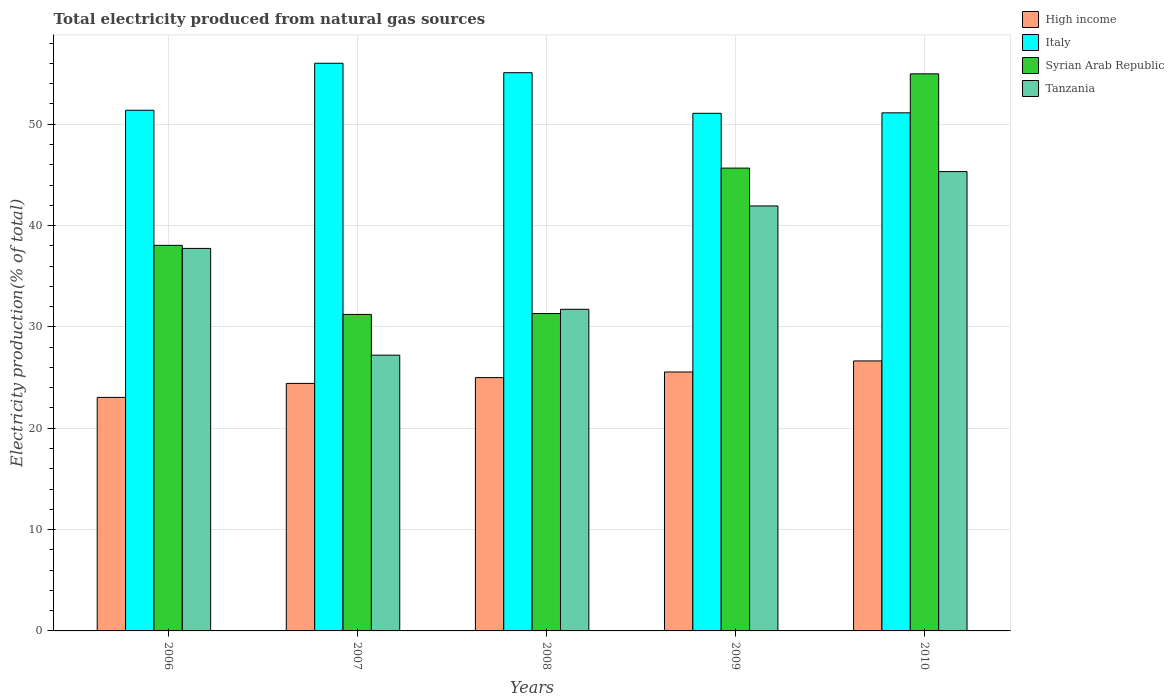Are the number of bars on each tick of the X-axis equal?
Offer a very short reply. Yes. How many bars are there on the 5th tick from the left?
Offer a very short reply. 4. In how many cases, is the number of bars for a given year not equal to the number of legend labels?
Provide a short and direct response. 0. What is the total electricity produced in High income in 2010?
Make the answer very short. 26.64. Across all years, what is the maximum total electricity produced in Syrian Arab Republic?
Offer a terse response. 54.97. Across all years, what is the minimum total electricity produced in Syrian Arab Republic?
Offer a terse response. 31.23. In which year was the total electricity produced in Syrian Arab Republic minimum?
Your response must be concise. 2007. What is the total total electricity produced in Italy in the graph?
Provide a succinct answer. 264.67. What is the difference between the total electricity produced in Syrian Arab Republic in 2006 and that in 2007?
Your answer should be very brief. 6.82. What is the difference between the total electricity produced in Italy in 2007 and the total electricity produced in High income in 2006?
Offer a very short reply. 32.97. What is the average total electricity produced in High income per year?
Provide a succinct answer. 24.93. In the year 2007, what is the difference between the total electricity produced in Tanzania and total electricity produced in Italy?
Make the answer very short. -28.8. What is the ratio of the total electricity produced in High income in 2007 to that in 2009?
Offer a very short reply. 0.96. Is the total electricity produced in High income in 2006 less than that in 2008?
Offer a terse response. Yes. What is the difference between the highest and the second highest total electricity produced in Italy?
Your response must be concise. 0.93. What is the difference between the highest and the lowest total electricity produced in Syrian Arab Republic?
Give a very brief answer. 23.74. In how many years, is the total electricity produced in Italy greater than the average total electricity produced in Italy taken over all years?
Your answer should be compact. 2. Is the sum of the total electricity produced in High income in 2007 and 2008 greater than the maximum total electricity produced in Tanzania across all years?
Keep it short and to the point. Yes. Is it the case that in every year, the sum of the total electricity produced in Italy and total electricity produced in Tanzania is greater than the sum of total electricity produced in Syrian Arab Republic and total electricity produced in High income?
Your response must be concise. No. What does the 1st bar from the left in 2006 represents?
Give a very brief answer. High income. What does the 2nd bar from the right in 2010 represents?
Your response must be concise. Syrian Arab Republic. How many bars are there?
Ensure brevity in your answer.  20. Are all the bars in the graph horizontal?
Ensure brevity in your answer.  No. What is the difference between two consecutive major ticks on the Y-axis?
Make the answer very short. 10. Does the graph contain grids?
Your answer should be very brief. Yes. What is the title of the graph?
Give a very brief answer. Total electricity produced from natural gas sources. What is the label or title of the X-axis?
Your answer should be compact. Years. What is the Electricity production(% of total) of High income in 2006?
Make the answer very short. 23.04. What is the Electricity production(% of total) in Italy in 2006?
Ensure brevity in your answer.  51.38. What is the Electricity production(% of total) in Syrian Arab Republic in 2006?
Ensure brevity in your answer.  38.05. What is the Electricity production(% of total) of Tanzania in 2006?
Your answer should be compact. 37.74. What is the Electricity production(% of total) in High income in 2007?
Your response must be concise. 24.42. What is the Electricity production(% of total) of Italy in 2007?
Make the answer very short. 56.01. What is the Electricity production(% of total) in Syrian Arab Republic in 2007?
Provide a short and direct response. 31.23. What is the Electricity production(% of total) of Tanzania in 2007?
Keep it short and to the point. 27.21. What is the Electricity production(% of total) in High income in 2008?
Provide a succinct answer. 25. What is the Electricity production(% of total) of Italy in 2008?
Provide a short and direct response. 55.08. What is the Electricity production(% of total) of Syrian Arab Republic in 2008?
Your answer should be compact. 31.32. What is the Electricity production(% of total) of Tanzania in 2008?
Give a very brief answer. 31.74. What is the Electricity production(% of total) in High income in 2009?
Offer a very short reply. 25.55. What is the Electricity production(% of total) of Italy in 2009?
Keep it short and to the point. 51.08. What is the Electricity production(% of total) in Syrian Arab Republic in 2009?
Provide a short and direct response. 45.67. What is the Electricity production(% of total) in Tanzania in 2009?
Offer a terse response. 41.93. What is the Electricity production(% of total) of High income in 2010?
Offer a very short reply. 26.64. What is the Electricity production(% of total) in Italy in 2010?
Ensure brevity in your answer.  51.12. What is the Electricity production(% of total) in Syrian Arab Republic in 2010?
Your answer should be compact. 54.97. What is the Electricity production(% of total) in Tanzania in 2010?
Offer a very short reply. 45.32. Across all years, what is the maximum Electricity production(% of total) of High income?
Your answer should be very brief. 26.64. Across all years, what is the maximum Electricity production(% of total) in Italy?
Give a very brief answer. 56.01. Across all years, what is the maximum Electricity production(% of total) in Syrian Arab Republic?
Offer a terse response. 54.97. Across all years, what is the maximum Electricity production(% of total) in Tanzania?
Your answer should be very brief. 45.32. Across all years, what is the minimum Electricity production(% of total) in High income?
Keep it short and to the point. 23.04. Across all years, what is the minimum Electricity production(% of total) of Italy?
Make the answer very short. 51.08. Across all years, what is the minimum Electricity production(% of total) in Syrian Arab Republic?
Keep it short and to the point. 31.23. Across all years, what is the minimum Electricity production(% of total) in Tanzania?
Offer a very short reply. 27.21. What is the total Electricity production(% of total) in High income in the graph?
Your answer should be compact. 124.65. What is the total Electricity production(% of total) of Italy in the graph?
Your answer should be compact. 264.67. What is the total Electricity production(% of total) in Syrian Arab Republic in the graph?
Provide a succinct answer. 201.23. What is the total Electricity production(% of total) in Tanzania in the graph?
Keep it short and to the point. 183.95. What is the difference between the Electricity production(% of total) of High income in 2006 and that in 2007?
Ensure brevity in your answer.  -1.38. What is the difference between the Electricity production(% of total) in Italy in 2006 and that in 2007?
Make the answer very short. -4.64. What is the difference between the Electricity production(% of total) of Syrian Arab Republic in 2006 and that in 2007?
Provide a succinct answer. 6.82. What is the difference between the Electricity production(% of total) of Tanzania in 2006 and that in 2007?
Provide a succinct answer. 10.53. What is the difference between the Electricity production(% of total) in High income in 2006 and that in 2008?
Make the answer very short. -1.95. What is the difference between the Electricity production(% of total) in Italy in 2006 and that in 2008?
Your answer should be compact. -3.71. What is the difference between the Electricity production(% of total) of Syrian Arab Republic in 2006 and that in 2008?
Your response must be concise. 6.73. What is the difference between the Electricity production(% of total) of Tanzania in 2006 and that in 2008?
Your answer should be very brief. 6.01. What is the difference between the Electricity production(% of total) of High income in 2006 and that in 2009?
Make the answer very short. -2.51. What is the difference between the Electricity production(% of total) in Italy in 2006 and that in 2009?
Keep it short and to the point. 0.3. What is the difference between the Electricity production(% of total) in Syrian Arab Republic in 2006 and that in 2009?
Your response must be concise. -7.62. What is the difference between the Electricity production(% of total) of Tanzania in 2006 and that in 2009?
Offer a terse response. -4.19. What is the difference between the Electricity production(% of total) of High income in 2006 and that in 2010?
Provide a short and direct response. -3.6. What is the difference between the Electricity production(% of total) of Italy in 2006 and that in 2010?
Your response must be concise. 0.25. What is the difference between the Electricity production(% of total) in Syrian Arab Republic in 2006 and that in 2010?
Your answer should be very brief. -16.92. What is the difference between the Electricity production(% of total) of Tanzania in 2006 and that in 2010?
Your answer should be compact. -7.58. What is the difference between the Electricity production(% of total) in High income in 2007 and that in 2008?
Give a very brief answer. -0.57. What is the difference between the Electricity production(% of total) in Italy in 2007 and that in 2008?
Keep it short and to the point. 0.93. What is the difference between the Electricity production(% of total) of Syrian Arab Republic in 2007 and that in 2008?
Provide a succinct answer. -0.09. What is the difference between the Electricity production(% of total) in Tanzania in 2007 and that in 2008?
Offer a very short reply. -4.53. What is the difference between the Electricity production(% of total) in High income in 2007 and that in 2009?
Your response must be concise. -1.13. What is the difference between the Electricity production(% of total) of Italy in 2007 and that in 2009?
Make the answer very short. 4.94. What is the difference between the Electricity production(% of total) in Syrian Arab Republic in 2007 and that in 2009?
Provide a succinct answer. -14.44. What is the difference between the Electricity production(% of total) of Tanzania in 2007 and that in 2009?
Ensure brevity in your answer.  -14.72. What is the difference between the Electricity production(% of total) in High income in 2007 and that in 2010?
Make the answer very short. -2.22. What is the difference between the Electricity production(% of total) of Italy in 2007 and that in 2010?
Provide a short and direct response. 4.89. What is the difference between the Electricity production(% of total) in Syrian Arab Republic in 2007 and that in 2010?
Give a very brief answer. -23.74. What is the difference between the Electricity production(% of total) of Tanzania in 2007 and that in 2010?
Give a very brief answer. -18.11. What is the difference between the Electricity production(% of total) of High income in 2008 and that in 2009?
Ensure brevity in your answer.  -0.56. What is the difference between the Electricity production(% of total) of Italy in 2008 and that in 2009?
Make the answer very short. 4.01. What is the difference between the Electricity production(% of total) of Syrian Arab Republic in 2008 and that in 2009?
Your response must be concise. -14.35. What is the difference between the Electricity production(% of total) of Tanzania in 2008 and that in 2009?
Provide a short and direct response. -10.2. What is the difference between the Electricity production(% of total) of High income in 2008 and that in 2010?
Make the answer very short. -1.65. What is the difference between the Electricity production(% of total) of Italy in 2008 and that in 2010?
Offer a terse response. 3.96. What is the difference between the Electricity production(% of total) in Syrian Arab Republic in 2008 and that in 2010?
Your answer should be very brief. -23.65. What is the difference between the Electricity production(% of total) in Tanzania in 2008 and that in 2010?
Ensure brevity in your answer.  -13.59. What is the difference between the Electricity production(% of total) of High income in 2009 and that in 2010?
Keep it short and to the point. -1.09. What is the difference between the Electricity production(% of total) in Italy in 2009 and that in 2010?
Your answer should be compact. -0.05. What is the difference between the Electricity production(% of total) of Syrian Arab Republic in 2009 and that in 2010?
Ensure brevity in your answer.  -9.3. What is the difference between the Electricity production(% of total) of Tanzania in 2009 and that in 2010?
Offer a terse response. -3.39. What is the difference between the Electricity production(% of total) in High income in 2006 and the Electricity production(% of total) in Italy in 2007?
Ensure brevity in your answer.  -32.97. What is the difference between the Electricity production(% of total) in High income in 2006 and the Electricity production(% of total) in Syrian Arab Republic in 2007?
Provide a succinct answer. -8.19. What is the difference between the Electricity production(% of total) of High income in 2006 and the Electricity production(% of total) of Tanzania in 2007?
Your answer should be very brief. -4.17. What is the difference between the Electricity production(% of total) of Italy in 2006 and the Electricity production(% of total) of Syrian Arab Republic in 2007?
Give a very brief answer. 20.15. What is the difference between the Electricity production(% of total) in Italy in 2006 and the Electricity production(% of total) in Tanzania in 2007?
Your answer should be compact. 24.16. What is the difference between the Electricity production(% of total) in Syrian Arab Republic in 2006 and the Electricity production(% of total) in Tanzania in 2007?
Make the answer very short. 10.84. What is the difference between the Electricity production(% of total) of High income in 2006 and the Electricity production(% of total) of Italy in 2008?
Ensure brevity in your answer.  -32.04. What is the difference between the Electricity production(% of total) in High income in 2006 and the Electricity production(% of total) in Syrian Arab Republic in 2008?
Keep it short and to the point. -8.27. What is the difference between the Electricity production(% of total) in High income in 2006 and the Electricity production(% of total) in Tanzania in 2008?
Your response must be concise. -8.69. What is the difference between the Electricity production(% of total) of Italy in 2006 and the Electricity production(% of total) of Syrian Arab Republic in 2008?
Keep it short and to the point. 20.06. What is the difference between the Electricity production(% of total) in Italy in 2006 and the Electricity production(% of total) in Tanzania in 2008?
Provide a succinct answer. 19.64. What is the difference between the Electricity production(% of total) in Syrian Arab Republic in 2006 and the Electricity production(% of total) in Tanzania in 2008?
Offer a very short reply. 6.31. What is the difference between the Electricity production(% of total) of High income in 2006 and the Electricity production(% of total) of Italy in 2009?
Provide a succinct answer. -28.03. What is the difference between the Electricity production(% of total) in High income in 2006 and the Electricity production(% of total) in Syrian Arab Republic in 2009?
Offer a very short reply. -22.63. What is the difference between the Electricity production(% of total) in High income in 2006 and the Electricity production(% of total) in Tanzania in 2009?
Offer a very short reply. -18.89. What is the difference between the Electricity production(% of total) in Italy in 2006 and the Electricity production(% of total) in Syrian Arab Republic in 2009?
Ensure brevity in your answer.  5.71. What is the difference between the Electricity production(% of total) of Italy in 2006 and the Electricity production(% of total) of Tanzania in 2009?
Your answer should be very brief. 9.44. What is the difference between the Electricity production(% of total) of Syrian Arab Republic in 2006 and the Electricity production(% of total) of Tanzania in 2009?
Ensure brevity in your answer.  -3.89. What is the difference between the Electricity production(% of total) of High income in 2006 and the Electricity production(% of total) of Italy in 2010?
Offer a terse response. -28.08. What is the difference between the Electricity production(% of total) of High income in 2006 and the Electricity production(% of total) of Syrian Arab Republic in 2010?
Keep it short and to the point. -31.93. What is the difference between the Electricity production(% of total) in High income in 2006 and the Electricity production(% of total) in Tanzania in 2010?
Make the answer very short. -22.28. What is the difference between the Electricity production(% of total) of Italy in 2006 and the Electricity production(% of total) of Syrian Arab Republic in 2010?
Offer a terse response. -3.59. What is the difference between the Electricity production(% of total) in Italy in 2006 and the Electricity production(% of total) in Tanzania in 2010?
Your answer should be compact. 6.05. What is the difference between the Electricity production(% of total) in Syrian Arab Republic in 2006 and the Electricity production(% of total) in Tanzania in 2010?
Make the answer very short. -7.28. What is the difference between the Electricity production(% of total) in High income in 2007 and the Electricity production(% of total) in Italy in 2008?
Give a very brief answer. -30.66. What is the difference between the Electricity production(% of total) in High income in 2007 and the Electricity production(% of total) in Syrian Arab Republic in 2008?
Make the answer very short. -6.89. What is the difference between the Electricity production(% of total) in High income in 2007 and the Electricity production(% of total) in Tanzania in 2008?
Give a very brief answer. -7.31. What is the difference between the Electricity production(% of total) of Italy in 2007 and the Electricity production(% of total) of Syrian Arab Republic in 2008?
Make the answer very short. 24.7. What is the difference between the Electricity production(% of total) in Italy in 2007 and the Electricity production(% of total) in Tanzania in 2008?
Offer a terse response. 24.28. What is the difference between the Electricity production(% of total) in Syrian Arab Republic in 2007 and the Electricity production(% of total) in Tanzania in 2008?
Give a very brief answer. -0.51. What is the difference between the Electricity production(% of total) of High income in 2007 and the Electricity production(% of total) of Italy in 2009?
Your answer should be compact. -26.65. What is the difference between the Electricity production(% of total) in High income in 2007 and the Electricity production(% of total) in Syrian Arab Republic in 2009?
Give a very brief answer. -21.24. What is the difference between the Electricity production(% of total) of High income in 2007 and the Electricity production(% of total) of Tanzania in 2009?
Provide a short and direct response. -17.51. What is the difference between the Electricity production(% of total) in Italy in 2007 and the Electricity production(% of total) in Syrian Arab Republic in 2009?
Offer a very short reply. 10.35. What is the difference between the Electricity production(% of total) in Italy in 2007 and the Electricity production(% of total) in Tanzania in 2009?
Provide a succinct answer. 14.08. What is the difference between the Electricity production(% of total) in Syrian Arab Republic in 2007 and the Electricity production(% of total) in Tanzania in 2009?
Provide a short and direct response. -10.7. What is the difference between the Electricity production(% of total) of High income in 2007 and the Electricity production(% of total) of Italy in 2010?
Provide a succinct answer. -26.7. What is the difference between the Electricity production(% of total) of High income in 2007 and the Electricity production(% of total) of Syrian Arab Republic in 2010?
Provide a short and direct response. -30.54. What is the difference between the Electricity production(% of total) in High income in 2007 and the Electricity production(% of total) in Tanzania in 2010?
Ensure brevity in your answer.  -20.9. What is the difference between the Electricity production(% of total) of Italy in 2007 and the Electricity production(% of total) of Syrian Arab Republic in 2010?
Ensure brevity in your answer.  1.04. What is the difference between the Electricity production(% of total) of Italy in 2007 and the Electricity production(% of total) of Tanzania in 2010?
Your answer should be compact. 10.69. What is the difference between the Electricity production(% of total) of Syrian Arab Republic in 2007 and the Electricity production(% of total) of Tanzania in 2010?
Keep it short and to the point. -14.09. What is the difference between the Electricity production(% of total) of High income in 2008 and the Electricity production(% of total) of Italy in 2009?
Provide a succinct answer. -26.08. What is the difference between the Electricity production(% of total) of High income in 2008 and the Electricity production(% of total) of Syrian Arab Republic in 2009?
Offer a terse response. -20.67. What is the difference between the Electricity production(% of total) of High income in 2008 and the Electricity production(% of total) of Tanzania in 2009?
Ensure brevity in your answer.  -16.94. What is the difference between the Electricity production(% of total) of Italy in 2008 and the Electricity production(% of total) of Syrian Arab Republic in 2009?
Your answer should be very brief. 9.41. What is the difference between the Electricity production(% of total) in Italy in 2008 and the Electricity production(% of total) in Tanzania in 2009?
Your answer should be compact. 13.15. What is the difference between the Electricity production(% of total) in Syrian Arab Republic in 2008 and the Electricity production(% of total) in Tanzania in 2009?
Provide a succinct answer. -10.62. What is the difference between the Electricity production(% of total) in High income in 2008 and the Electricity production(% of total) in Italy in 2010?
Your answer should be very brief. -26.13. What is the difference between the Electricity production(% of total) in High income in 2008 and the Electricity production(% of total) in Syrian Arab Republic in 2010?
Your response must be concise. -29.97. What is the difference between the Electricity production(% of total) of High income in 2008 and the Electricity production(% of total) of Tanzania in 2010?
Provide a succinct answer. -20.33. What is the difference between the Electricity production(% of total) of Italy in 2008 and the Electricity production(% of total) of Syrian Arab Republic in 2010?
Your answer should be very brief. 0.11. What is the difference between the Electricity production(% of total) in Italy in 2008 and the Electricity production(% of total) in Tanzania in 2010?
Your answer should be compact. 9.76. What is the difference between the Electricity production(% of total) of Syrian Arab Republic in 2008 and the Electricity production(% of total) of Tanzania in 2010?
Make the answer very short. -14.01. What is the difference between the Electricity production(% of total) in High income in 2009 and the Electricity production(% of total) in Italy in 2010?
Your answer should be very brief. -25.57. What is the difference between the Electricity production(% of total) in High income in 2009 and the Electricity production(% of total) in Syrian Arab Republic in 2010?
Provide a succinct answer. -29.42. What is the difference between the Electricity production(% of total) in High income in 2009 and the Electricity production(% of total) in Tanzania in 2010?
Make the answer very short. -19.77. What is the difference between the Electricity production(% of total) of Italy in 2009 and the Electricity production(% of total) of Syrian Arab Republic in 2010?
Offer a very short reply. -3.89. What is the difference between the Electricity production(% of total) in Italy in 2009 and the Electricity production(% of total) in Tanzania in 2010?
Make the answer very short. 5.75. What is the difference between the Electricity production(% of total) of Syrian Arab Republic in 2009 and the Electricity production(% of total) of Tanzania in 2010?
Offer a terse response. 0.34. What is the average Electricity production(% of total) of High income per year?
Your response must be concise. 24.93. What is the average Electricity production(% of total) in Italy per year?
Your answer should be very brief. 52.93. What is the average Electricity production(% of total) in Syrian Arab Republic per year?
Ensure brevity in your answer.  40.25. What is the average Electricity production(% of total) in Tanzania per year?
Offer a terse response. 36.79. In the year 2006, what is the difference between the Electricity production(% of total) in High income and Electricity production(% of total) in Italy?
Offer a terse response. -28.33. In the year 2006, what is the difference between the Electricity production(% of total) in High income and Electricity production(% of total) in Syrian Arab Republic?
Give a very brief answer. -15. In the year 2006, what is the difference between the Electricity production(% of total) in High income and Electricity production(% of total) in Tanzania?
Keep it short and to the point. -14.7. In the year 2006, what is the difference between the Electricity production(% of total) of Italy and Electricity production(% of total) of Syrian Arab Republic?
Your answer should be very brief. 13.33. In the year 2006, what is the difference between the Electricity production(% of total) of Italy and Electricity production(% of total) of Tanzania?
Give a very brief answer. 13.63. In the year 2006, what is the difference between the Electricity production(% of total) of Syrian Arab Republic and Electricity production(% of total) of Tanzania?
Your answer should be very brief. 0.3. In the year 2007, what is the difference between the Electricity production(% of total) of High income and Electricity production(% of total) of Italy?
Ensure brevity in your answer.  -31.59. In the year 2007, what is the difference between the Electricity production(% of total) of High income and Electricity production(% of total) of Syrian Arab Republic?
Your response must be concise. -6.81. In the year 2007, what is the difference between the Electricity production(% of total) in High income and Electricity production(% of total) in Tanzania?
Make the answer very short. -2.79. In the year 2007, what is the difference between the Electricity production(% of total) of Italy and Electricity production(% of total) of Syrian Arab Republic?
Give a very brief answer. 24.78. In the year 2007, what is the difference between the Electricity production(% of total) of Italy and Electricity production(% of total) of Tanzania?
Provide a short and direct response. 28.8. In the year 2007, what is the difference between the Electricity production(% of total) in Syrian Arab Republic and Electricity production(% of total) in Tanzania?
Provide a short and direct response. 4.02. In the year 2008, what is the difference between the Electricity production(% of total) of High income and Electricity production(% of total) of Italy?
Keep it short and to the point. -30.09. In the year 2008, what is the difference between the Electricity production(% of total) of High income and Electricity production(% of total) of Syrian Arab Republic?
Offer a very short reply. -6.32. In the year 2008, what is the difference between the Electricity production(% of total) of High income and Electricity production(% of total) of Tanzania?
Your answer should be very brief. -6.74. In the year 2008, what is the difference between the Electricity production(% of total) of Italy and Electricity production(% of total) of Syrian Arab Republic?
Your answer should be compact. 23.77. In the year 2008, what is the difference between the Electricity production(% of total) of Italy and Electricity production(% of total) of Tanzania?
Offer a terse response. 23.35. In the year 2008, what is the difference between the Electricity production(% of total) in Syrian Arab Republic and Electricity production(% of total) in Tanzania?
Keep it short and to the point. -0.42. In the year 2009, what is the difference between the Electricity production(% of total) in High income and Electricity production(% of total) in Italy?
Ensure brevity in your answer.  -25.53. In the year 2009, what is the difference between the Electricity production(% of total) of High income and Electricity production(% of total) of Syrian Arab Republic?
Give a very brief answer. -20.12. In the year 2009, what is the difference between the Electricity production(% of total) of High income and Electricity production(% of total) of Tanzania?
Your answer should be compact. -16.38. In the year 2009, what is the difference between the Electricity production(% of total) of Italy and Electricity production(% of total) of Syrian Arab Republic?
Offer a very short reply. 5.41. In the year 2009, what is the difference between the Electricity production(% of total) in Italy and Electricity production(% of total) in Tanzania?
Ensure brevity in your answer.  9.14. In the year 2009, what is the difference between the Electricity production(% of total) of Syrian Arab Republic and Electricity production(% of total) of Tanzania?
Make the answer very short. 3.73. In the year 2010, what is the difference between the Electricity production(% of total) of High income and Electricity production(% of total) of Italy?
Give a very brief answer. -24.48. In the year 2010, what is the difference between the Electricity production(% of total) in High income and Electricity production(% of total) in Syrian Arab Republic?
Your response must be concise. -28.33. In the year 2010, what is the difference between the Electricity production(% of total) in High income and Electricity production(% of total) in Tanzania?
Your answer should be compact. -18.68. In the year 2010, what is the difference between the Electricity production(% of total) in Italy and Electricity production(% of total) in Syrian Arab Republic?
Offer a very short reply. -3.85. In the year 2010, what is the difference between the Electricity production(% of total) in Italy and Electricity production(% of total) in Tanzania?
Give a very brief answer. 5.8. In the year 2010, what is the difference between the Electricity production(% of total) of Syrian Arab Republic and Electricity production(% of total) of Tanzania?
Ensure brevity in your answer.  9.64. What is the ratio of the Electricity production(% of total) of High income in 2006 to that in 2007?
Your answer should be very brief. 0.94. What is the ratio of the Electricity production(% of total) of Italy in 2006 to that in 2007?
Your answer should be compact. 0.92. What is the ratio of the Electricity production(% of total) of Syrian Arab Republic in 2006 to that in 2007?
Make the answer very short. 1.22. What is the ratio of the Electricity production(% of total) of Tanzania in 2006 to that in 2007?
Your answer should be very brief. 1.39. What is the ratio of the Electricity production(% of total) of High income in 2006 to that in 2008?
Provide a short and direct response. 0.92. What is the ratio of the Electricity production(% of total) in Italy in 2006 to that in 2008?
Offer a very short reply. 0.93. What is the ratio of the Electricity production(% of total) in Syrian Arab Republic in 2006 to that in 2008?
Ensure brevity in your answer.  1.21. What is the ratio of the Electricity production(% of total) of Tanzania in 2006 to that in 2008?
Provide a succinct answer. 1.19. What is the ratio of the Electricity production(% of total) in High income in 2006 to that in 2009?
Make the answer very short. 0.9. What is the ratio of the Electricity production(% of total) of Italy in 2006 to that in 2009?
Keep it short and to the point. 1.01. What is the ratio of the Electricity production(% of total) in Syrian Arab Republic in 2006 to that in 2009?
Provide a succinct answer. 0.83. What is the ratio of the Electricity production(% of total) of Tanzania in 2006 to that in 2009?
Provide a short and direct response. 0.9. What is the ratio of the Electricity production(% of total) of High income in 2006 to that in 2010?
Provide a short and direct response. 0.86. What is the ratio of the Electricity production(% of total) of Syrian Arab Republic in 2006 to that in 2010?
Make the answer very short. 0.69. What is the ratio of the Electricity production(% of total) in Tanzania in 2006 to that in 2010?
Keep it short and to the point. 0.83. What is the ratio of the Electricity production(% of total) in High income in 2007 to that in 2008?
Your response must be concise. 0.98. What is the ratio of the Electricity production(% of total) of Italy in 2007 to that in 2008?
Keep it short and to the point. 1.02. What is the ratio of the Electricity production(% of total) in Tanzania in 2007 to that in 2008?
Keep it short and to the point. 0.86. What is the ratio of the Electricity production(% of total) in High income in 2007 to that in 2009?
Offer a very short reply. 0.96. What is the ratio of the Electricity production(% of total) in Italy in 2007 to that in 2009?
Provide a short and direct response. 1.1. What is the ratio of the Electricity production(% of total) in Syrian Arab Republic in 2007 to that in 2009?
Your answer should be compact. 0.68. What is the ratio of the Electricity production(% of total) in Tanzania in 2007 to that in 2009?
Give a very brief answer. 0.65. What is the ratio of the Electricity production(% of total) of High income in 2007 to that in 2010?
Keep it short and to the point. 0.92. What is the ratio of the Electricity production(% of total) in Italy in 2007 to that in 2010?
Your answer should be compact. 1.1. What is the ratio of the Electricity production(% of total) in Syrian Arab Republic in 2007 to that in 2010?
Provide a succinct answer. 0.57. What is the ratio of the Electricity production(% of total) in Tanzania in 2007 to that in 2010?
Offer a very short reply. 0.6. What is the ratio of the Electricity production(% of total) in High income in 2008 to that in 2009?
Provide a succinct answer. 0.98. What is the ratio of the Electricity production(% of total) of Italy in 2008 to that in 2009?
Ensure brevity in your answer.  1.08. What is the ratio of the Electricity production(% of total) in Syrian Arab Republic in 2008 to that in 2009?
Your answer should be compact. 0.69. What is the ratio of the Electricity production(% of total) of Tanzania in 2008 to that in 2009?
Your answer should be compact. 0.76. What is the ratio of the Electricity production(% of total) in High income in 2008 to that in 2010?
Keep it short and to the point. 0.94. What is the ratio of the Electricity production(% of total) in Italy in 2008 to that in 2010?
Offer a very short reply. 1.08. What is the ratio of the Electricity production(% of total) in Syrian Arab Republic in 2008 to that in 2010?
Offer a terse response. 0.57. What is the ratio of the Electricity production(% of total) in Tanzania in 2008 to that in 2010?
Make the answer very short. 0.7. What is the ratio of the Electricity production(% of total) in High income in 2009 to that in 2010?
Keep it short and to the point. 0.96. What is the ratio of the Electricity production(% of total) of Syrian Arab Republic in 2009 to that in 2010?
Offer a terse response. 0.83. What is the ratio of the Electricity production(% of total) in Tanzania in 2009 to that in 2010?
Your answer should be very brief. 0.93. What is the difference between the highest and the second highest Electricity production(% of total) in Italy?
Offer a very short reply. 0.93. What is the difference between the highest and the second highest Electricity production(% of total) of Syrian Arab Republic?
Your answer should be compact. 9.3. What is the difference between the highest and the second highest Electricity production(% of total) in Tanzania?
Offer a very short reply. 3.39. What is the difference between the highest and the lowest Electricity production(% of total) of High income?
Give a very brief answer. 3.6. What is the difference between the highest and the lowest Electricity production(% of total) in Italy?
Keep it short and to the point. 4.94. What is the difference between the highest and the lowest Electricity production(% of total) of Syrian Arab Republic?
Ensure brevity in your answer.  23.74. What is the difference between the highest and the lowest Electricity production(% of total) in Tanzania?
Your response must be concise. 18.11. 